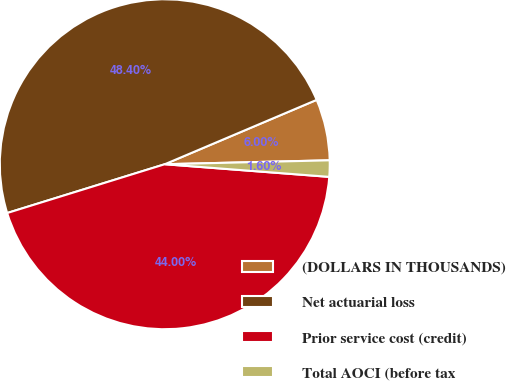<chart> <loc_0><loc_0><loc_500><loc_500><pie_chart><fcel>(DOLLARS IN THOUSANDS)<fcel>Net actuarial loss<fcel>Prior service cost (credit)<fcel>Total AOCI (before tax<nl><fcel>6.0%<fcel>48.4%<fcel>44.0%<fcel>1.6%<nl></chart> 